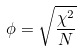<formula> <loc_0><loc_0><loc_500><loc_500>\phi = \sqrt { \frac { \chi ^ { 2 } } { N } }</formula> 